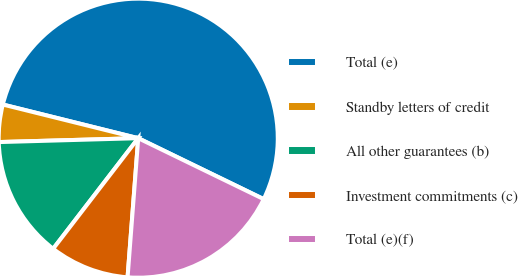Convert chart. <chart><loc_0><loc_0><loc_500><loc_500><pie_chart><fcel>Total (e)<fcel>Standby letters of credit<fcel>All other guarantees (b)<fcel>Investment commitments (c)<fcel>Total (e)(f)<nl><fcel>53.32%<fcel>4.32%<fcel>14.12%<fcel>9.22%<fcel>19.02%<nl></chart> 